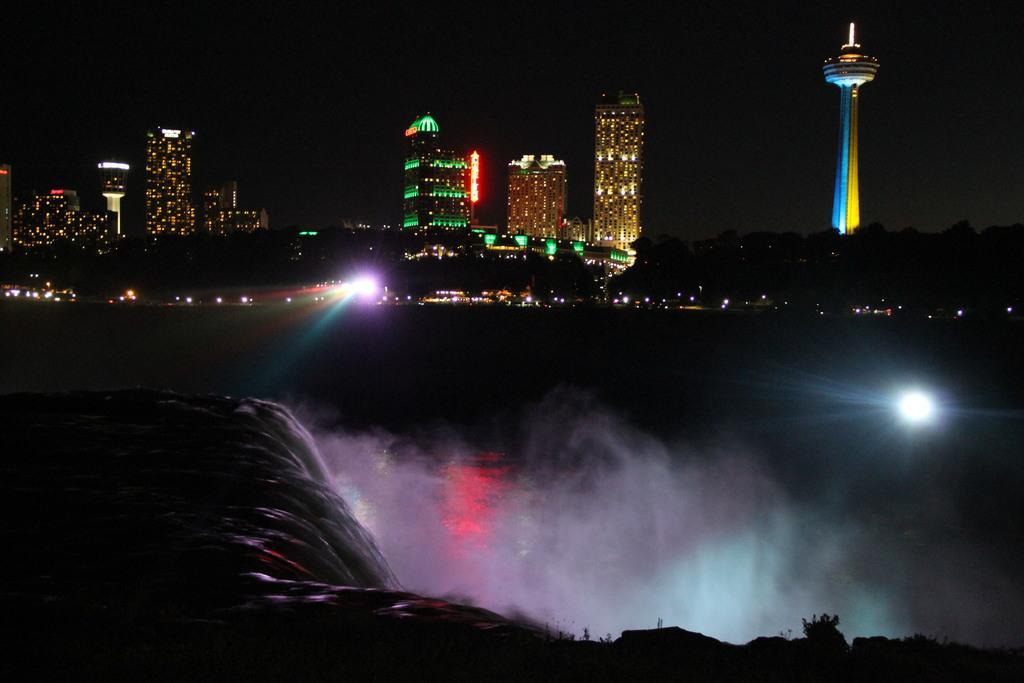Could you give a brief overview of what you see in this image? This image is taken outdoors. At the bottom of the image there is a waterfall with water. In this image the background is dark. In the middle of the image there are a few buildings and skyscrapers and there are a few lights. On the right side of the image there is a tower. 